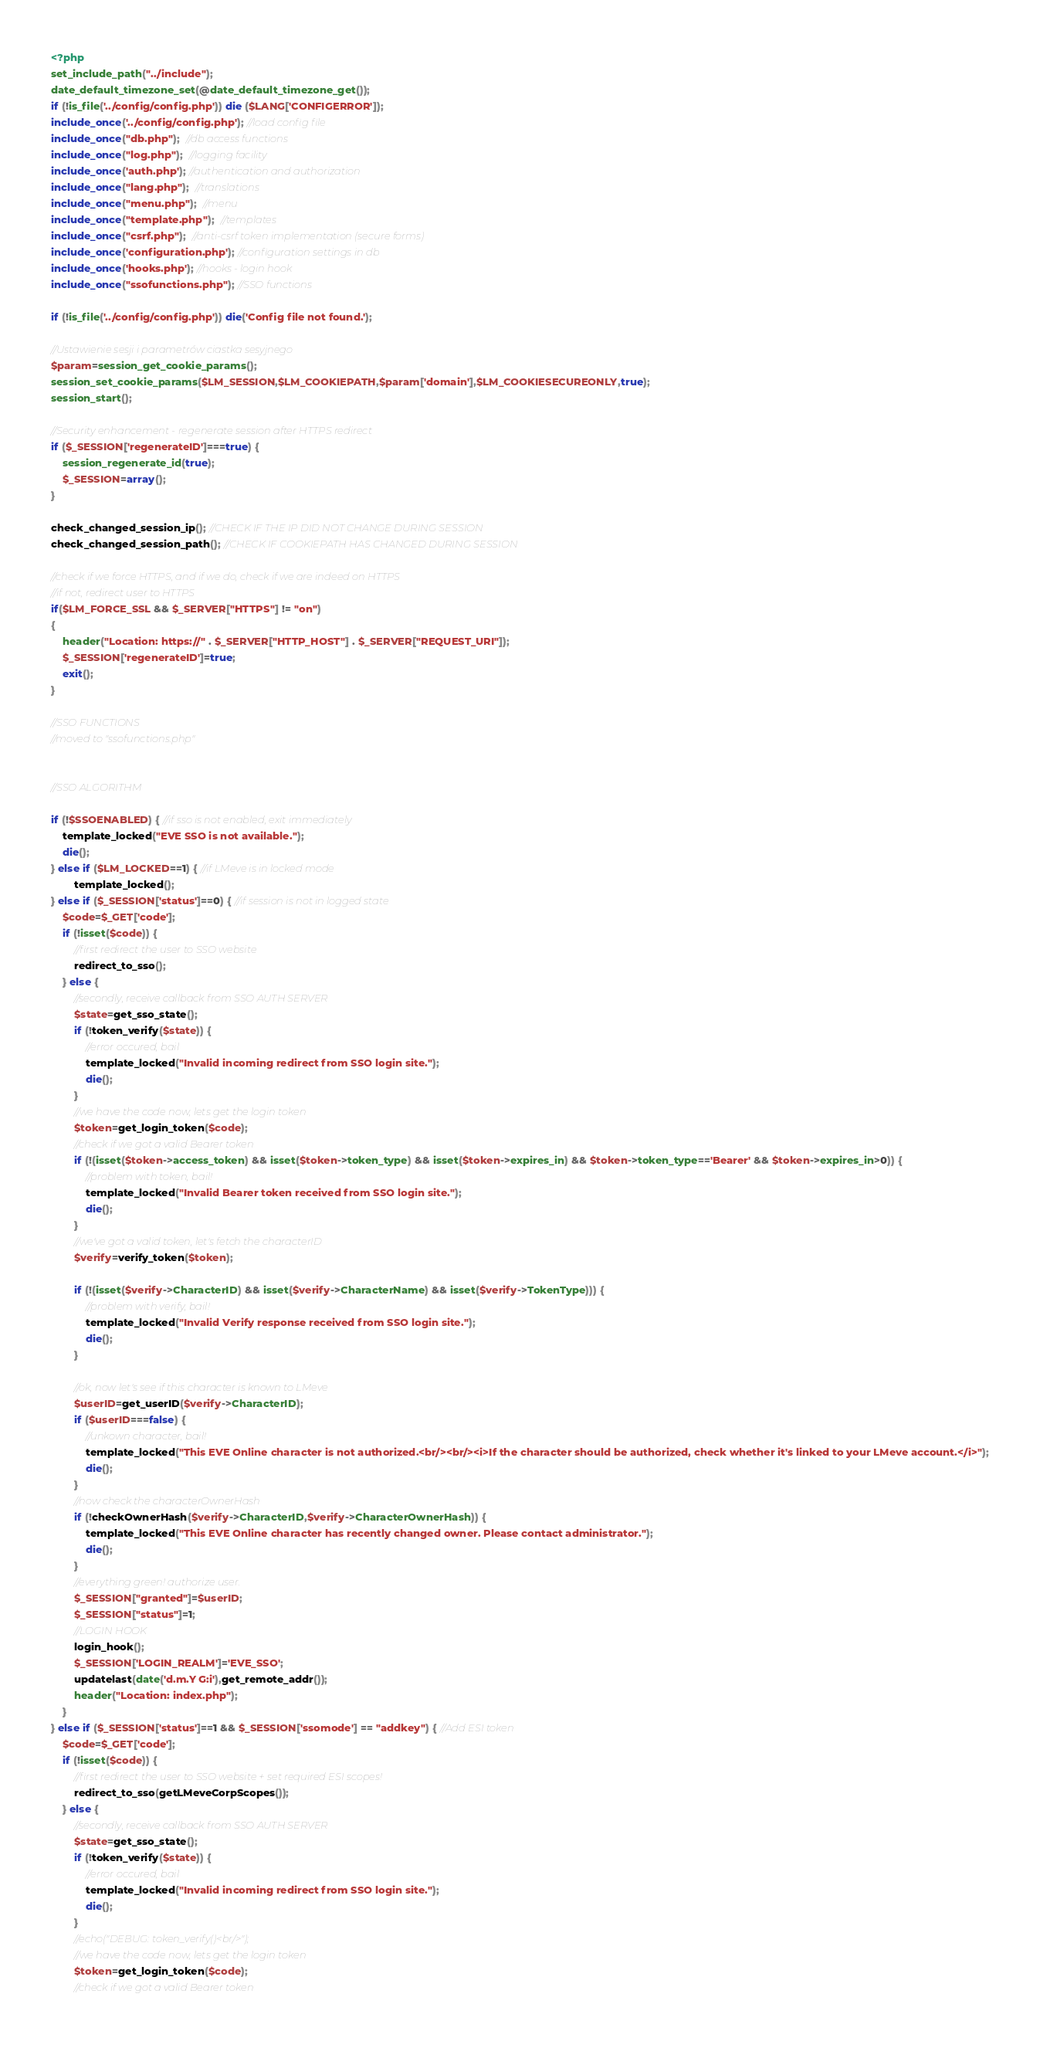<code> <loc_0><loc_0><loc_500><loc_500><_PHP_><?php
set_include_path("../include");
date_default_timezone_set(@date_default_timezone_get());
if (!is_file('../config/config.php')) die ($LANG['CONFIGERROR']);
include_once('../config/config.php'); //load config file
include_once("db.php");  //db access functions
include_once("log.php");  //logging facility
include_once('auth.php'); //authentication and authorization
include_once("lang.php");  //translations
include_once("menu.php");  //menu
include_once("template.php");  //templates
include_once("csrf.php");  //anti-csrf token implementation (secure forms)
include_once('configuration.php'); //configuration settings in db
include_once('hooks.php'); //hooks - login hook
include_once("ssofunctions.php"); //SSO functions

if (!is_file('../config/config.php')) die('Config file not found.');
 
//Ustawienie sesji i parametrów ciastka sesyjnego
$param=session_get_cookie_params();
session_set_cookie_params($LM_SESSION,$LM_COOKIEPATH,$param['domain'],$LM_COOKIESECUREONLY,true);
session_start();

//Security enhancement - regenerate session after HTTPS redirect
if ($_SESSION['regenerateID']===true) {
    session_regenerate_id(true);
    $_SESSION=array();
}

check_changed_session_ip(); //CHECK IF THE IP DID NOT CHANGE DURING SESSION
check_changed_session_path(); //CHECK IF COOKIEPATH HAS CHANGED DURING SESSION

//check if we force HTTPS, and if we do, check if we are indeed on HTTPS
//if not, redirect user to HTTPS
if($LM_FORCE_SSL && $_SERVER["HTTPS"] != "on")
{
    header("Location: https://" . $_SERVER["HTTP_HOST"] . $_SERVER["REQUEST_URI"]);
    $_SESSION['regenerateID']=true;
    exit();
}

//SSO FUNCTIONS
//moved to "ssofunctions.php"


//SSO ALGORITHM

if (!$SSOENABLED) { //if sso is not enabled, exit immediately
    template_locked("EVE SSO is not available.");
    die();
} else if ($LM_LOCKED==1) { //if LMeve is in locked mode
        template_locked();
} else if ($_SESSION['status']==0) { //if session is not in logged state
    $code=$_GET['code'];
    if (!isset($code)) {
        //first redirect the user to SSO website
        redirect_to_sso();
    } else {
        //secondly, receive callback from SSO AUTH SERVER
        $state=get_sso_state();
        if (!token_verify($state)) {
            //error occured, bail
            template_locked("Invalid incoming redirect from SSO login site.");
            die();
        }
        //we have the code now, lets get the login token
        $token=get_login_token($code);
        //check if we got a valid Bearer token
        if (!(isset($token->access_token) && isset($token->token_type) && isset($token->expires_in) && $token->token_type=='Bearer' && $token->expires_in>0)) {
            //problem with token, bail!
            template_locked("Invalid Bearer token received from SSO login site.");
            die();
        }
        //we've got a valid token, let's fetch the characterID 
        $verify=verify_token($token);

        if (!(isset($verify->CharacterID) && isset($verify->CharacterName) && isset($verify->TokenType))) {
            //problem with verify, bail!
            template_locked("Invalid Verify response received from SSO login site.");
            die();
        }
        
        //ok, now let's see if this character is known to LMeve
        $userID=get_userID($verify->CharacterID);
        if ($userID===false) {
            //unkown character, bail!
            template_locked("This EVE Online character is not authorized.<br/><br/><i>If the character should be authorized, check whether it's linked to your LMeve account.</i>");
            die();
        }
        //now check the characterOwnerHash
        if (!checkOwnerHash($verify->CharacterID,$verify->CharacterOwnerHash)) {
            template_locked("This EVE Online character has recently changed owner. Please contact administrator.");
            die();
        }
        //everything green! authorize user.
        $_SESSION["granted"]=$userID;
        $_SESSION["status"]=1;
        //LOGIN HOOK
        login_hook();
        $_SESSION['LOGIN_REALM']='EVE_SSO';
        updatelast(date('d.m.Y G:i'),get_remote_addr());
        header("Location: index.php");
    }
} else if ($_SESSION['status']==1 && $_SESSION['ssomode'] == "addkey") { //Add ESI token
    $code=$_GET['code'];
    if (!isset($code)) {
        //first redirect the user to SSO website + set required ESI scopes!
        redirect_to_sso(getLMeveCorpScopes());
    } else {
        //secondly, receive callback from SSO AUTH SERVER
        $state=get_sso_state();
        if (!token_verify($state)) {
            //error occured, bail
            template_locked("Invalid incoming redirect from SSO login site.");
            die();
        }
        //echo("DEBUG: token_verify()<br/>");
        //we have the code now, lets get the login token
        $token=get_login_token($code);
        //check if we got a valid Bearer token</code> 